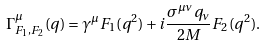Convert formula to latex. <formula><loc_0><loc_0><loc_500><loc_500>\Gamma ^ { \mu } _ { F _ { 1 } , F _ { 2 } } ( q ) = \gamma ^ { \mu } F _ { 1 } ( q ^ { 2 } ) + i \frac { \sigma ^ { \mu \nu } q _ { \nu } } { 2 M } F _ { 2 } ( q ^ { 2 } ) .</formula> 